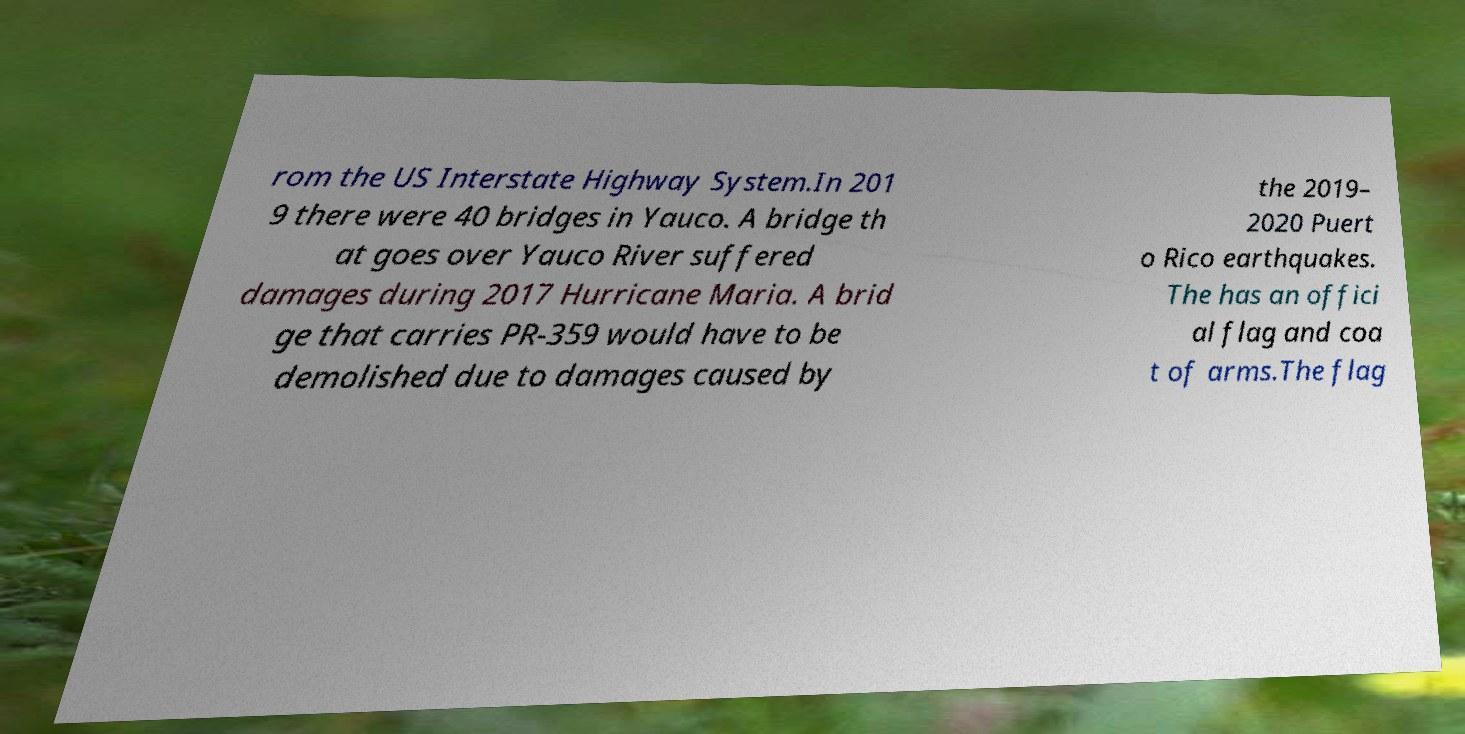What messages or text are displayed in this image? I need them in a readable, typed format. rom the US Interstate Highway System.In 201 9 there were 40 bridges in Yauco. A bridge th at goes over Yauco River suffered damages during 2017 Hurricane Maria. A brid ge that carries PR-359 would have to be demolished due to damages caused by the 2019– 2020 Puert o Rico earthquakes. The has an offici al flag and coa t of arms.The flag 